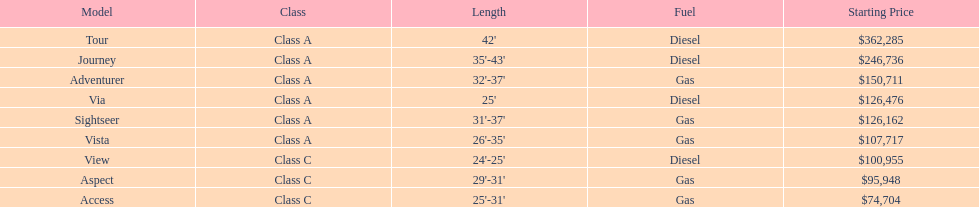What is the designation of the most expensive winnebago model? Tour. 